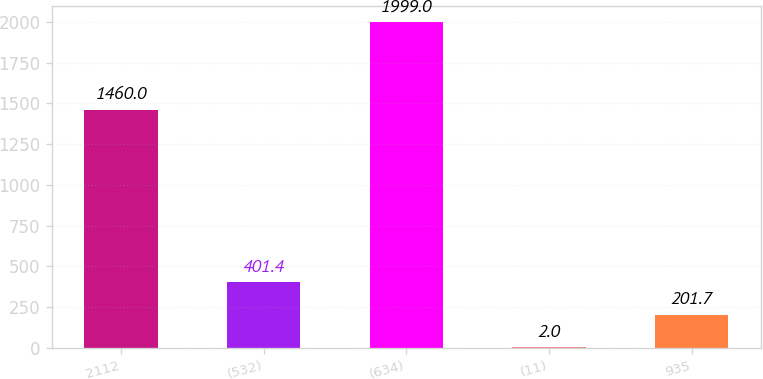Convert chart. <chart><loc_0><loc_0><loc_500><loc_500><bar_chart><fcel>2112<fcel>(532)<fcel>(634)<fcel>(11)<fcel>935<nl><fcel>1460<fcel>401.4<fcel>1999<fcel>2<fcel>201.7<nl></chart> 